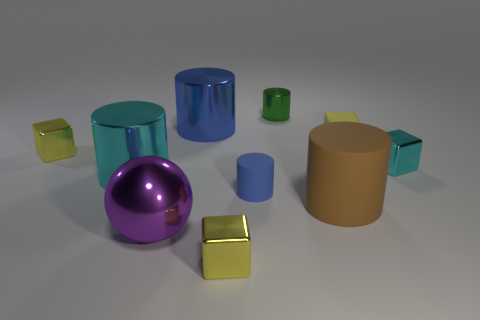Subtract all brown cylinders. How many cylinders are left? 4 Subtract all brown cylinders. How many cylinders are left? 4 Subtract 3 cylinders. How many cylinders are left? 2 Subtract all purple blocks. Subtract all green spheres. How many blocks are left? 4 Subtract all blue spheres. How many blue cubes are left? 0 Subtract all purple shiny objects. Subtract all small yellow rubber things. How many objects are left? 8 Add 6 rubber cylinders. How many rubber cylinders are left? 8 Add 6 large purple things. How many large purple things exist? 7 Subtract 1 cyan cylinders. How many objects are left? 9 Subtract all balls. How many objects are left? 9 